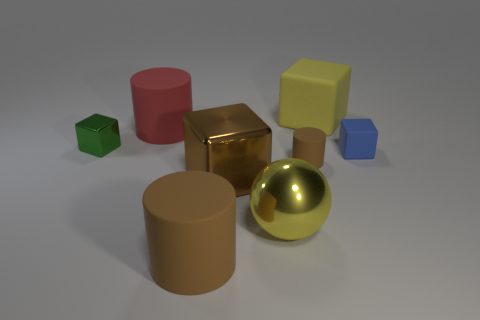Add 1 blue rubber cubes. How many objects exist? 9 Subtract all brown cylinders. How many cylinders are left? 1 Subtract all blue cubes. How many cubes are left? 3 Subtract all blue cubes. How many red cylinders are left? 1 Subtract 3 cylinders. How many cylinders are left? 0 Subtract all blue blocks. Subtract all purple spheres. How many blocks are left? 3 Subtract all brown rubber cylinders. Subtract all green things. How many objects are left? 5 Add 3 green metallic things. How many green metallic things are left? 4 Add 4 yellow rubber things. How many yellow rubber things exist? 5 Subtract 0 gray balls. How many objects are left? 8 